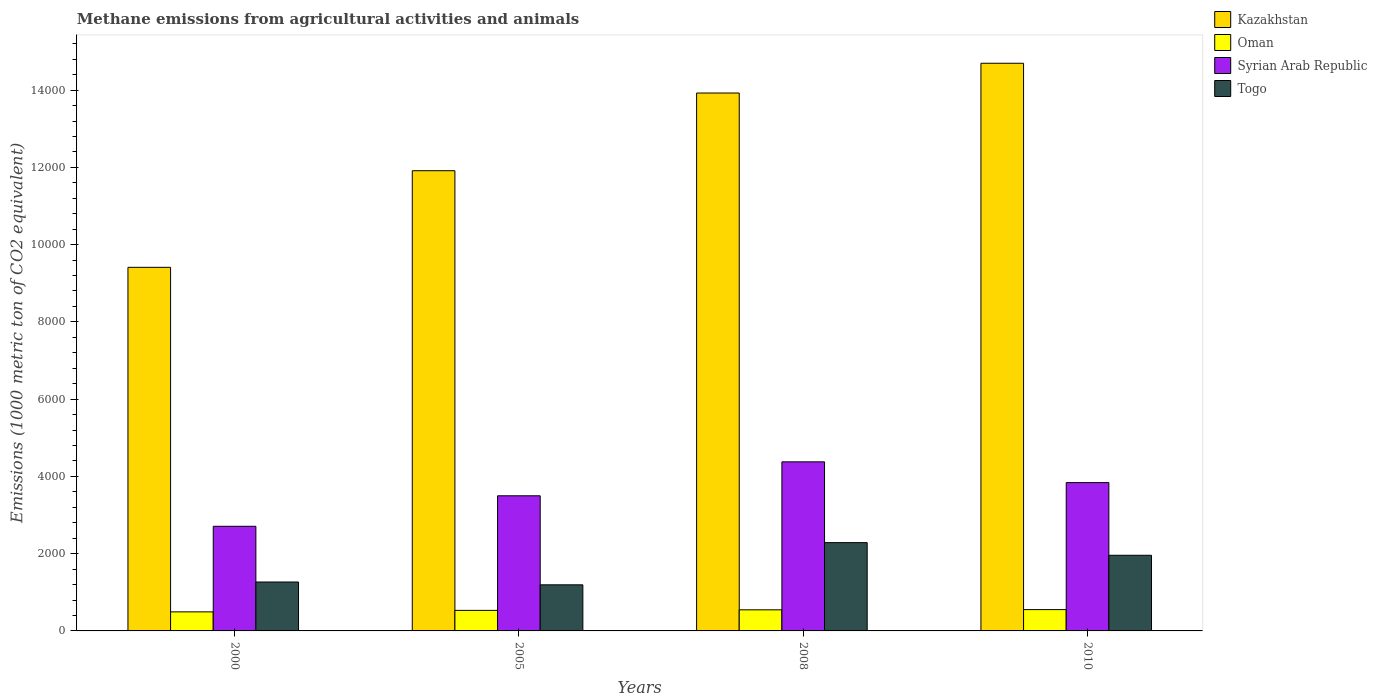How many different coloured bars are there?
Ensure brevity in your answer.  4. How many groups of bars are there?
Give a very brief answer. 4. How many bars are there on the 3rd tick from the right?
Your answer should be compact. 4. What is the label of the 3rd group of bars from the left?
Your answer should be very brief. 2008. In how many cases, is the number of bars for a given year not equal to the number of legend labels?
Provide a succinct answer. 0. What is the amount of methane emitted in Oman in 2008?
Your answer should be compact. 546.4. Across all years, what is the maximum amount of methane emitted in Kazakhstan?
Your response must be concise. 1.47e+04. Across all years, what is the minimum amount of methane emitted in Oman?
Make the answer very short. 493.2. What is the total amount of methane emitted in Kazakhstan in the graph?
Provide a succinct answer. 4.99e+04. What is the difference between the amount of methane emitted in Togo in 2000 and that in 2010?
Provide a succinct answer. -692.3. What is the difference between the amount of methane emitted in Oman in 2008 and the amount of methane emitted in Kazakhstan in 2005?
Make the answer very short. -1.14e+04. What is the average amount of methane emitted in Oman per year?
Offer a very short reply. 530.8. In the year 2000, what is the difference between the amount of methane emitted in Togo and amount of methane emitted in Syrian Arab Republic?
Keep it short and to the point. -1442.6. In how many years, is the amount of methane emitted in Syrian Arab Republic greater than 12000 1000 metric ton?
Make the answer very short. 0. What is the ratio of the amount of methane emitted in Oman in 2000 to that in 2008?
Provide a short and direct response. 0.9. Is the difference between the amount of methane emitted in Togo in 2000 and 2008 greater than the difference between the amount of methane emitted in Syrian Arab Republic in 2000 and 2008?
Keep it short and to the point. Yes. What is the difference between the highest and the second highest amount of methane emitted in Kazakhstan?
Your answer should be very brief. 770.6. What is the difference between the highest and the lowest amount of methane emitted in Syrian Arab Republic?
Give a very brief answer. 1668. Is it the case that in every year, the sum of the amount of methane emitted in Oman and amount of methane emitted in Kazakhstan is greater than the sum of amount of methane emitted in Togo and amount of methane emitted in Syrian Arab Republic?
Provide a succinct answer. Yes. What does the 3rd bar from the left in 2000 represents?
Give a very brief answer. Syrian Arab Republic. What does the 1st bar from the right in 2000 represents?
Make the answer very short. Togo. How many bars are there?
Provide a succinct answer. 16. How many years are there in the graph?
Make the answer very short. 4. What is the difference between two consecutive major ticks on the Y-axis?
Keep it short and to the point. 2000. Are the values on the major ticks of Y-axis written in scientific E-notation?
Provide a succinct answer. No. Does the graph contain grids?
Offer a terse response. No. How many legend labels are there?
Your answer should be very brief. 4. What is the title of the graph?
Your response must be concise. Methane emissions from agricultural activities and animals. What is the label or title of the Y-axis?
Provide a succinct answer. Emissions (1000 metric ton of CO2 equivalent). What is the Emissions (1000 metric ton of CO2 equivalent) in Kazakhstan in 2000?
Make the answer very short. 9412.4. What is the Emissions (1000 metric ton of CO2 equivalent) of Oman in 2000?
Your answer should be very brief. 493.2. What is the Emissions (1000 metric ton of CO2 equivalent) in Syrian Arab Republic in 2000?
Your answer should be compact. 2708.8. What is the Emissions (1000 metric ton of CO2 equivalent) in Togo in 2000?
Make the answer very short. 1266.2. What is the Emissions (1000 metric ton of CO2 equivalent) in Kazakhstan in 2005?
Your response must be concise. 1.19e+04. What is the Emissions (1000 metric ton of CO2 equivalent) in Oman in 2005?
Keep it short and to the point. 531.8. What is the Emissions (1000 metric ton of CO2 equivalent) in Syrian Arab Republic in 2005?
Offer a terse response. 3498.3. What is the Emissions (1000 metric ton of CO2 equivalent) in Togo in 2005?
Ensure brevity in your answer.  1193.3. What is the Emissions (1000 metric ton of CO2 equivalent) of Kazakhstan in 2008?
Your answer should be very brief. 1.39e+04. What is the Emissions (1000 metric ton of CO2 equivalent) of Oman in 2008?
Your response must be concise. 546.4. What is the Emissions (1000 metric ton of CO2 equivalent) in Syrian Arab Republic in 2008?
Your answer should be compact. 4376.8. What is the Emissions (1000 metric ton of CO2 equivalent) of Togo in 2008?
Your answer should be very brief. 2285.6. What is the Emissions (1000 metric ton of CO2 equivalent) in Kazakhstan in 2010?
Make the answer very short. 1.47e+04. What is the Emissions (1000 metric ton of CO2 equivalent) of Oman in 2010?
Ensure brevity in your answer.  551.8. What is the Emissions (1000 metric ton of CO2 equivalent) in Syrian Arab Republic in 2010?
Offer a very short reply. 3839.8. What is the Emissions (1000 metric ton of CO2 equivalent) in Togo in 2010?
Ensure brevity in your answer.  1958.5. Across all years, what is the maximum Emissions (1000 metric ton of CO2 equivalent) of Kazakhstan?
Offer a terse response. 1.47e+04. Across all years, what is the maximum Emissions (1000 metric ton of CO2 equivalent) in Oman?
Offer a very short reply. 551.8. Across all years, what is the maximum Emissions (1000 metric ton of CO2 equivalent) of Syrian Arab Republic?
Make the answer very short. 4376.8. Across all years, what is the maximum Emissions (1000 metric ton of CO2 equivalent) of Togo?
Give a very brief answer. 2285.6. Across all years, what is the minimum Emissions (1000 metric ton of CO2 equivalent) of Kazakhstan?
Give a very brief answer. 9412.4. Across all years, what is the minimum Emissions (1000 metric ton of CO2 equivalent) of Oman?
Offer a terse response. 493.2. Across all years, what is the minimum Emissions (1000 metric ton of CO2 equivalent) of Syrian Arab Republic?
Give a very brief answer. 2708.8. Across all years, what is the minimum Emissions (1000 metric ton of CO2 equivalent) of Togo?
Keep it short and to the point. 1193.3. What is the total Emissions (1000 metric ton of CO2 equivalent) in Kazakhstan in the graph?
Keep it short and to the point. 4.99e+04. What is the total Emissions (1000 metric ton of CO2 equivalent) of Oman in the graph?
Keep it short and to the point. 2123.2. What is the total Emissions (1000 metric ton of CO2 equivalent) in Syrian Arab Republic in the graph?
Ensure brevity in your answer.  1.44e+04. What is the total Emissions (1000 metric ton of CO2 equivalent) in Togo in the graph?
Ensure brevity in your answer.  6703.6. What is the difference between the Emissions (1000 metric ton of CO2 equivalent) of Kazakhstan in 2000 and that in 2005?
Your answer should be very brief. -2501.3. What is the difference between the Emissions (1000 metric ton of CO2 equivalent) of Oman in 2000 and that in 2005?
Provide a succinct answer. -38.6. What is the difference between the Emissions (1000 metric ton of CO2 equivalent) in Syrian Arab Republic in 2000 and that in 2005?
Offer a very short reply. -789.5. What is the difference between the Emissions (1000 metric ton of CO2 equivalent) of Togo in 2000 and that in 2005?
Your answer should be compact. 72.9. What is the difference between the Emissions (1000 metric ton of CO2 equivalent) of Kazakhstan in 2000 and that in 2008?
Keep it short and to the point. -4512.5. What is the difference between the Emissions (1000 metric ton of CO2 equivalent) of Oman in 2000 and that in 2008?
Offer a terse response. -53.2. What is the difference between the Emissions (1000 metric ton of CO2 equivalent) of Syrian Arab Republic in 2000 and that in 2008?
Give a very brief answer. -1668. What is the difference between the Emissions (1000 metric ton of CO2 equivalent) in Togo in 2000 and that in 2008?
Make the answer very short. -1019.4. What is the difference between the Emissions (1000 metric ton of CO2 equivalent) in Kazakhstan in 2000 and that in 2010?
Your answer should be very brief. -5283.1. What is the difference between the Emissions (1000 metric ton of CO2 equivalent) of Oman in 2000 and that in 2010?
Give a very brief answer. -58.6. What is the difference between the Emissions (1000 metric ton of CO2 equivalent) in Syrian Arab Republic in 2000 and that in 2010?
Your response must be concise. -1131. What is the difference between the Emissions (1000 metric ton of CO2 equivalent) in Togo in 2000 and that in 2010?
Your answer should be compact. -692.3. What is the difference between the Emissions (1000 metric ton of CO2 equivalent) in Kazakhstan in 2005 and that in 2008?
Make the answer very short. -2011.2. What is the difference between the Emissions (1000 metric ton of CO2 equivalent) in Oman in 2005 and that in 2008?
Give a very brief answer. -14.6. What is the difference between the Emissions (1000 metric ton of CO2 equivalent) of Syrian Arab Republic in 2005 and that in 2008?
Keep it short and to the point. -878.5. What is the difference between the Emissions (1000 metric ton of CO2 equivalent) of Togo in 2005 and that in 2008?
Ensure brevity in your answer.  -1092.3. What is the difference between the Emissions (1000 metric ton of CO2 equivalent) in Kazakhstan in 2005 and that in 2010?
Your answer should be very brief. -2781.8. What is the difference between the Emissions (1000 metric ton of CO2 equivalent) of Oman in 2005 and that in 2010?
Provide a succinct answer. -20. What is the difference between the Emissions (1000 metric ton of CO2 equivalent) in Syrian Arab Republic in 2005 and that in 2010?
Keep it short and to the point. -341.5. What is the difference between the Emissions (1000 metric ton of CO2 equivalent) in Togo in 2005 and that in 2010?
Give a very brief answer. -765.2. What is the difference between the Emissions (1000 metric ton of CO2 equivalent) in Kazakhstan in 2008 and that in 2010?
Your response must be concise. -770.6. What is the difference between the Emissions (1000 metric ton of CO2 equivalent) in Syrian Arab Republic in 2008 and that in 2010?
Ensure brevity in your answer.  537. What is the difference between the Emissions (1000 metric ton of CO2 equivalent) in Togo in 2008 and that in 2010?
Your answer should be very brief. 327.1. What is the difference between the Emissions (1000 metric ton of CO2 equivalent) of Kazakhstan in 2000 and the Emissions (1000 metric ton of CO2 equivalent) of Oman in 2005?
Give a very brief answer. 8880.6. What is the difference between the Emissions (1000 metric ton of CO2 equivalent) of Kazakhstan in 2000 and the Emissions (1000 metric ton of CO2 equivalent) of Syrian Arab Republic in 2005?
Ensure brevity in your answer.  5914.1. What is the difference between the Emissions (1000 metric ton of CO2 equivalent) of Kazakhstan in 2000 and the Emissions (1000 metric ton of CO2 equivalent) of Togo in 2005?
Your answer should be very brief. 8219.1. What is the difference between the Emissions (1000 metric ton of CO2 equivalent) in Oman in 2000 and the Emissions (1000 metric ton of CO2 equivalent) in Syrian Arab Republic in 2005?
Provide a short and direct response. -3005.1. What is the difference between the Emissions (1000 metric ton of CO2 equivalent) in Oman in 2000 and the Emissions (1000 metric ton of CO2 equivalent) in Togo in 2005?
Provide a short and direct response. -700.1. What is the difference between the Emissions (1000 metric ton of CO2 equivalent) of Syrian Arab Republic in 2000 and the Emissions (1000 metric ton of CO2 equivalent) of Togo in 2005?
Make the answer very short. 1515.5. What is the difference between the Emissions (1000 metric ton of CO2 equivalent) in Kazakhstan in 2000 and the Emissions (1000 metric ton of CO2 equivalent) in Oman in 2008?
Ensure brevity in your answer.  8866. What is the difference between the Emissions (1000 metric ton of CO2 equivalent) in Kazakhstan in 2000 and the Emissions (1000 metric ton of CO2 equivalent) in Syrian Arab Republic in 2008?
Your response must be concise. 5035.6. What is the difference between the Emissions (1000 metric ton of CO2 equivalent) of Kazakhstan in 2000 and the Emissions (1000 metric ton of CO2 equivalent) of Togo in 2008?
Provide a succinct answer. 7126.8. What is the difference between the Emissions (1000 metric ton of CO2 equivalent) in Oman in 2000 and the Emissions (1000 metric ton of CO2 equivalent) in Syrian Arab Republic in 2008?
Keep it short and to the point. -3883.6. What is the difference between the Emissions (1000 metric ton of CO2 equivalent) in Oman in 2000 and the Emissions (1000 metric ton of CO2 equivalent) in Togo in 2008?
Your response must be concise. -1792.4. What is the difference between the Emissions (1000 metric ton of CO2 equivalent) of Syrian Arab Republic in 2000 and the Emissions (1000 metric ton of CO2 equivalent) of Togo in 2008?
Provide a short and direct response. 423.2. What is the difference between the Emissions (1000 metric ton of CO2 equivalent) in Kazakhstan in 2000 and the Emissions (1000 metric ton of CO2 equivalent) in Oman in 2010?
Provide a short and direct response. 8860.6. What is the difference between the Emissions (1000 metric ton of CO2 equivalent) of Kazakhstan in 2000 and the Emissions (1000 metric ton of CO2 equivalent) of Syrian Arab Republic in 2010?
Make the answer very short. 5572.6. What is the difference between the Emissions (1000 metric ton of CO2 equivalent) of Kazakhstan in 2000 and the Emissions (1000 metric ton of CO2 equivalent) of Togo in 2010?
Keep it short and to the point. 7453.9. What is the difference between the Emissions (1000 metric ton of CO2 equivalent) of Oman in 2000 and the Emissions (1000 metric ton of CO2 equivalent) of Syrian Arab Republic in 2010?
Keep it short and to the point. -3346.6. What is the difference between the Emissions (1000 metric ton of CO2 equivalent) of Oman in 2000 and the Emissions (1000 metric ton of CO2 equivalent) of Togo in 2010?
Provide a short and direct response. -1465.3. What is the difference between the Emissions (1000 metric ton of CO2 equivalent) of Syrian Arab Republic in 2000 and the Emissions (1000 metric ton of CO2 equivalent) of Togo in 2010?
Offer a very short reply. 750.3. What is the difference between the Emissions (1000 metric ton of CO2 equivalent) in Kazakhstan in 2005 and the Emissions (1000 metric ton of CO2 equivalent) in Oman in 2008?
Provide a succinct answer. 1.14e+04. What is the difference between the Emissions (1000 metric ton of CO2 equivalent) of Kazakhstan in 2005 and the Emissions (1000 metric ton of CO2 equivalent) of Syrian Arab Republic in 2008?
Give a very brief answer. 7536.9. What is the difference between the Emissions (1000 metric ton of CO2 equivalent) of Kazakhstan in 2005 and the Emissions (1000 metric ton of CO2 equivalent) of Togo in 2008?
Your answer should be very brief. 9628.1. What is the difference between the Emissions (1000 metric ton of CO2 equivalent) of Oman in 2005 and the Emissions (1000 metric ton of CO2 equivalent) of Syrian Arab Republic in 2008?
Give a very brief answer. -3845. What is the difference between the Emissions (1000 metric ton of CO2 equivalent) of Oman in 2005 and the Emissions (1000 metric ton of CO2 equivalent) of Togo in 2008?
Ensure brevity in your answer.  -1753.8. What is the difference between the Emissions (1000 metric ton of CO2 equivalent) of Syrian Arab Republic in 2005 and the Emissions (1000 metric ton of CO2 equivalent) of Togo in 2008?
Your answer should be compact. 1212.7. What is the difference between the Emissions (1000 metric ton of CO2 equivalent) of Kazakhstan in 2005 and the Emissions (1000 metric ton of CO2 equivalent) of Oman in 2010?
Keep it short and to the point. 1.14e+04. What is the difference between the Emissions (1000 metric ton of CO2 equivalent) in Kazakhstan in 2005 and the Emissions (1000 metric ton of CO2 equivalent) in Syrian Arab Republic in 2010?
Give a very brief answer. 8073.9. What is the difference between the Emissions (1000 metric ton of CO2 equivalent) of Kazakhstan in 2005 and the Emissions (1000 metric ton of CO2 equivalent) of Togo in 2010?
Provide a short and direct response. 9955.2. What is the difference between the Emissions (1000 metric ton of CO2 equivalent) of Oman in 2005 and the Emissions (1000 metric ton of CO2 equivalent) of Syrian Arab Republic in 2010?
Provide a succinct answer. -3308. What is the difference between the Emissions (1000 metric ton of CO2 equivalent) of Oman in 2005 and the Emissions (1000 metric ton of CO2 equivalent) of Togo in 2010?
Keep it short and to the point. -1426.7. What is the difference between the Emissions (1000 metric ton of CO2 equivalent) in Syrian Arab Republic in 2005 and the Emissions (1000 metric ton of CO2 equivalent) in Togo in 2010?
Offer a very short reply. 1539.8. What is the difference between the Emissions (1000 metric ton of CO2 equivalent) in Kazakhstan in 2008 and the Emissions (1000 metric ton of CO2 equivalent) in Oman in 2010?
Ensure brevity in your answer.  1.34e+04. What is the difference between the Emissions (1000 metric ton of CO2 equivalent) in Kazakhstan in 2008 and the Emissions (1000 metric ton of CO2 equivalent) in Syrian Arab Republic in 2010?
Your answer should be compact. 1.01e+04. What is the difference between the Emissions (1000 metric ton of CO2 equivalent) of Kazakhstan in 2008 and the Emissions (1000 metric ton of CO2 equivalent) of Togo in 2010?
Your answer should be compact. 1.20e+04. What is the difference between the Emissions (1000 metric ton of CO2 equivalent) in Oman in 2008 and the Emissions (1000 metric ton of CO2 equivalent) in Syrian Arab Republic in 2010?
Your response must be concise. -3293.4. What is the difference between the Emissions (1000 metric ton of CO2 equivalent) in Oman in 2008 and the Emissions (1000 metric ton of CO2 equivalent) in Togo in 2010?
Provide a succinct answer. -1412.1. What is the difference between the Emissions (1000 metric ton of CO2 equivalent) in Syrian Arab Republic in 2008 and the Emissions (1000 metric ton of CO2 equivalent) in Togo in 2010?
Offer a terse response. 2418.3. What is the average Emissions (1000 metric ton of CO2 equivalent) of Kazakhstan per year?
Your answer should be very brief. 1.25e+04. What is the average Emissions (1000 metric ton of CO2 equivalent) in Oman per year?
Provide a short and direct response. 530.8. What is the average Emissions (1000 metric ton of CO2 equivalent) in Syrian Arab Republic per year?
Give a very brief answer. 3605.93. What is the average Emissions (1000 metric ton of CO2 equivalent) of Togo per year?
Your response must be concise. 1675.9. In the year 2000, what is the difference between the Emissions (1000 metric ton of CO2 equivalent) of Kazakhstan and Emissions (1000 metric ton of CO2 equivalent) of Oman?
Provide a succinct answer. 8919.2. In the year 2000, what is the difference between the Emissions (1000 metric ton of CO2 equivalent) of Kazakhstan and Emissions (1000 metric ton of CO2 equivalent) of Syrian Arab Republic?
Offer a terse response. 6703.6. In the year 2000, what is the difference between the Emissions (1000 metric ton of CO2 equivalent) of Kazakhstan and Emissions (1000 metric ton of CO2 equivalent) of Togo?
Give a very brief answer. 8146.2. In the year 2000, what is the difference between the Emissions (1000 metric ton of CO2 equivalent) of Oman and Emissions (1000 metric ton of CO2 equivalent) of Syrian Arab Republic?
Offer a terse response. -2215.6. In the year 2000, what is the difference between the Emissions (1000 metric ton of CO2 equivalent) of Oman and Emissions (1000 metric ton of CO2 equivalent) of Togo?
Your response must be concise. -773. In the year 2000, what is the difference between the Emissions (1000 metric ton of CO2 equivalent) in Syrian Arab Republic and Emissions (1000 metric ton of CO2 equivalent) in Togo?
Provide a succinct answer. 1442.6. In the year 2005, what is the difference between the Emissions (1000 metric ton of CO2 equivalent) of Kazakhstan and Emissions (1000 metric ton of CO2 equivalent) of Oman?
Ensure brevity in your answer.  1.14e+04. In the year 2005, what is the difference between the Emissions (1000 metric ton of CO2 equivalent) in Kazakhstan and Emissions (1000 metric ton of CO2 equivalent) in Syrian Arab Republic?
Give a very brief answer. 8415.4. In the year 2005, what is the difference between the Emissions (1000 metric ton of CO2 equivalent) of Kazakhstan and Emissions (1000 metric ton of CO2 equivalent) of Togo?
Offer a very short reply. 1.07e+04. In the year 2005, what is the difference between the Emissions (1000 metric ton of CO2 equivalent) in Oman and Emissions (1000 metric ton of CO2 equivalent) in Syrian Arab Republic?
Offer a very short reply. -2966.5. In the year 2005, what is the difference between the Emissions (1000 metric ton of CO2 equivalent) in Oman and Emissions (1000 metric ton of CO2 equivalent) in Togo?
Keep it short and to the point. -661.5. In the year 2005, what is the difference between the Emissions (1000 metric ton of CO2 equivalent) of Syrian Arab Republic and Emissions (1000 metric ton of CO2 equivalent) of Togo?
Make the answer very short. 2305. In the year 2008, what is the difference between the Emissions (1000 metric ton of CO2 equivalent) in Kazakhstan and Emissions (1000 metric ton of CO2 equivalent) in Oman?
Offer a terse response. 1.34e+04. In the year 2008, what is the difference between the Emissions (1000 metric ton of CO2 equivalent) in Kazakhstan and Emissions (1000 metric ton of CO2 equivalent) in Syrian Arab Republic?
Offer a terse response. 9548.1. In the year 2008, what is the difference between the Emissions (1000 metric ton of CO2 equivalent) in Kazakhstan and Emissions (1000 metric ton of CO2 equivalent) in Togo?
Offer a very short reply. 1.16e+04. In the year 2008, what is the difference between the Emissions (1000 metric ton of CO2 equivalent) of Oman and Emissions (1000 metric ton of CO2 equivalent) of Syrian Arab Republic?
Offer a very short reply. -3830.4. In the year 2008, what is the difference between the Emissions (1000 metric ton of CO2 equivalent) in Oman and Emissions (1000 metric ton of CO2 equivalent) in Togo?
Your response must be concise. -1739.2. In the year 2008, what is the difference between the Emissions (1000 metric ton of CO2 equivalent) of Syrian Arab Republic and Emissions (1000 metric ton of CO2 equivalent) of Togo?
Provide a succinct answer. 2091.2. In the year 2010, what is the difference between the Emissions (1000 metric ton of CO2 equivalent) in Kazakhstan and Emissions (1000 metric ton of CO2 equivalent) in Oman?
Your response must be concise. 1.41e+04. In the year 2010, what is the difference between the Emissions (1000 metric ton of CO2 equivalent) of Kazakhstan and Emissions (1000 metric ton of CO2 equivalent) of Syrian Arab Republic?
Ensure brevity in your answer.  1.09e+04. In the year 2010, what is the difference between the Emissions (1000 metric ton of CO2 equivalent) of Kazakhstan and Emissions (1000 metric ton of CO2 equivalent) of Togo?
Offer a very short reply. 1.27e+04. In the year 2010, what is the difference between the Emissions (1000 metric ton of CO2 equivalent) in Oman and Emissions (1000 metric ton of CO2 equivalent) in Syrian Arab Republic?
Your response must be concise. -3288. In the year 2010, what is the difference between the Emissions (1000 metric ton of CO2 equivalent) of Oman and Emissions (1000 metric ton of CO2 equivalent) of Togo?
Give a very brief answer. -1406.7. In the year 2010, what is the difference between the Emissions (1000 metric ton of CO2 equivalent) of Syrian Arab Republic and Emissions (1000 metric ton of CO2 equivalent) of Togo?
Your answer should be compact. 1881.3. What is the ratio of the Emissions (1000 metric ton of CO2 equivalent) in Kazakhstan in 2000 to that in 2005?
Your answer should be compact. 0.79. What is the ratio of the Emissions (1000 metric ton of CO2 equivalent) in Oman in 2000 to that in 2005?
Make the answer very short. 0.93. What is the ratio of the Emissions (1000 metric ton of CO2 equivalent) of Syrian Arab Republic in 2000 to that in 2005?
Offer a terse response. 0.77. What is the ratio of the Emissions (1000 metric ton of CO2 equivalent) in Togo in 2000 to that in 2005?
Your answer should be compact. 1.06. What is the ratio of the Emissions (1000 metric ton of CO2 equivalent) in Kazakhstan in 2000 to that in 2008?
Offer a terse response. 0.68. What is the ratio of the Emissions (1000 metric ton of CO2 equivalent) of Oman in 2000 to that in 2008?
Ensure brevity in your answer.  0.9. What is the ratio of the Emissions (1000 metric ton of CO2 equivalent) of Syrian Arab Republic in 2000 to that in 2008?
Keep it short and to the point. 0.62. What is the ratio of the Emissions (1000 metric ton of CO2 equivalent) of Togo in 2000 to that in 2008?
Offer a very short reply. 0.55. What is the ratio of the Emissions (1000 metric ton of CO2 equivalent) of Kazakhstan in 2000 to that in 2010?
Your response must be concise. 0.64. What is the ratio of the Emissions (1000 metric ton of CO2 equivalent) in Oman in 2000 to that in 2010?
Make the answer very short. 0.89. What is the ratio of the Emissions (1000 metric ton of CO2 equivalent) of Syrian Arab Republic in 2000 to that in 2010?
Your answer should be very brief. 0.71. What is the ratio of the Emissions (1000 metric ton of CO2 equivalent) in Togo in 2000 to that in 2010?
Offer a terse response. 0.65. What is the ratio of the Emissions (1000 metric ton of CO2 equivalent) in Kazakhstan in 2005 to that in 2008?
Offer a very short reply. 0.86. What is the ratio of the Emissions (1000 metric ton of CO2 equivalent) in Oman in 2005 to that in 2008?
Your answer should be compact. 0.97. What is the ratio of the Emissions (1000 metric ton of CO2 equivalent) in Syrian Arab Republic in 2005 to that in 2008?
Make the answer very short. 0.8. What is the ratio of the Emissions (1000 metric ton of CO2 equivalent) in Togo in 2005 to that in 2008?
Provide a succinct answer. 0.52. What is the ratio of the Emissions (1000 metric ton of CO2 equivalent) in Kazakhstan in 2005 to that in 2010?
Offer a terse response. 0.81. What is the ratio of the Emissions (1000 metric ton of CO2 equivalent) of Oman in 2005 to that in 2010?
Offer a very short reply. 0.96. What is the ratio of the Emissions (1000 metric ton of CO2 equivalent) of Syrian Arab Republic in 2005 to that in 2010?
Offer a terse response. 0.91. What is the ratio of the Emissions (1000 metric ton of CO2 equivalent) of Togo in 2005 to that in 2010?
Offer a very short reply. 0.61. What is the ratio of the Emissions (1000 metric ton of CO2 equivalent) in Kazakhstan in 2008 to that in 2010?
Offer a terse response. 0.95. What is the ratio of the Emissions (1000 metric ton of CO2 equivalent) in Oman in 2008 to that in 2010?
Provide a short and direct response. 0.99. What is the ratio of the Emissions (1000 metric ton of CO2 equivalent) of Syrian Arab Republic in 2008 to that in 2010?
Your response must be concise. 1.14. What is the ratio of the Emissions (1000 metric ton of CO2 equivalent) in Togo in 2008 to that in 2010?
Provide a succinct answer. 1.17. What is the difference between the highest and the second highest Emissions (1000 metric ton of CO2 equivalent) in Kazakhstan?
Keep it short and to the point. 770.6. What is the difference between the highest and the second highest Emissions (1000 metric ton of CO2 equivalent) in Oman?
Provide a short and direct response. 5.4. What is the difference between the highest and the second highest Emissions (1000 metric ton of CO2 equivalent) of Syrian Arab Republic?
Provide a short and direct response. 537. What is the difference between the highest and the second highest Emissions (1000 metric ton of CO2 equivalent) in Togo?
Your response must be concise. 327.1. What is the difference between the highest and the lowest Emissions (1000 metric ton of CO2 equivalent) in Kazakhstan?
Offer a terse response. 5283.1. What is the difference between the highest and the lowest Emissions (1000 metric ton of CO2 equivalent) of Oman?
Keep it short and to the point. 58.6. What is the difference between the highest and the lowest Emissions (1000 metric ton of CO2 equivalent) of Syrian Arab Republic?
Make the answer very short. 1668. What is the difference between the highest and the lowest Emissions (1000 metric ton of CO2 equivalent) of Togo?
Your response must be concise. 1092.3. 